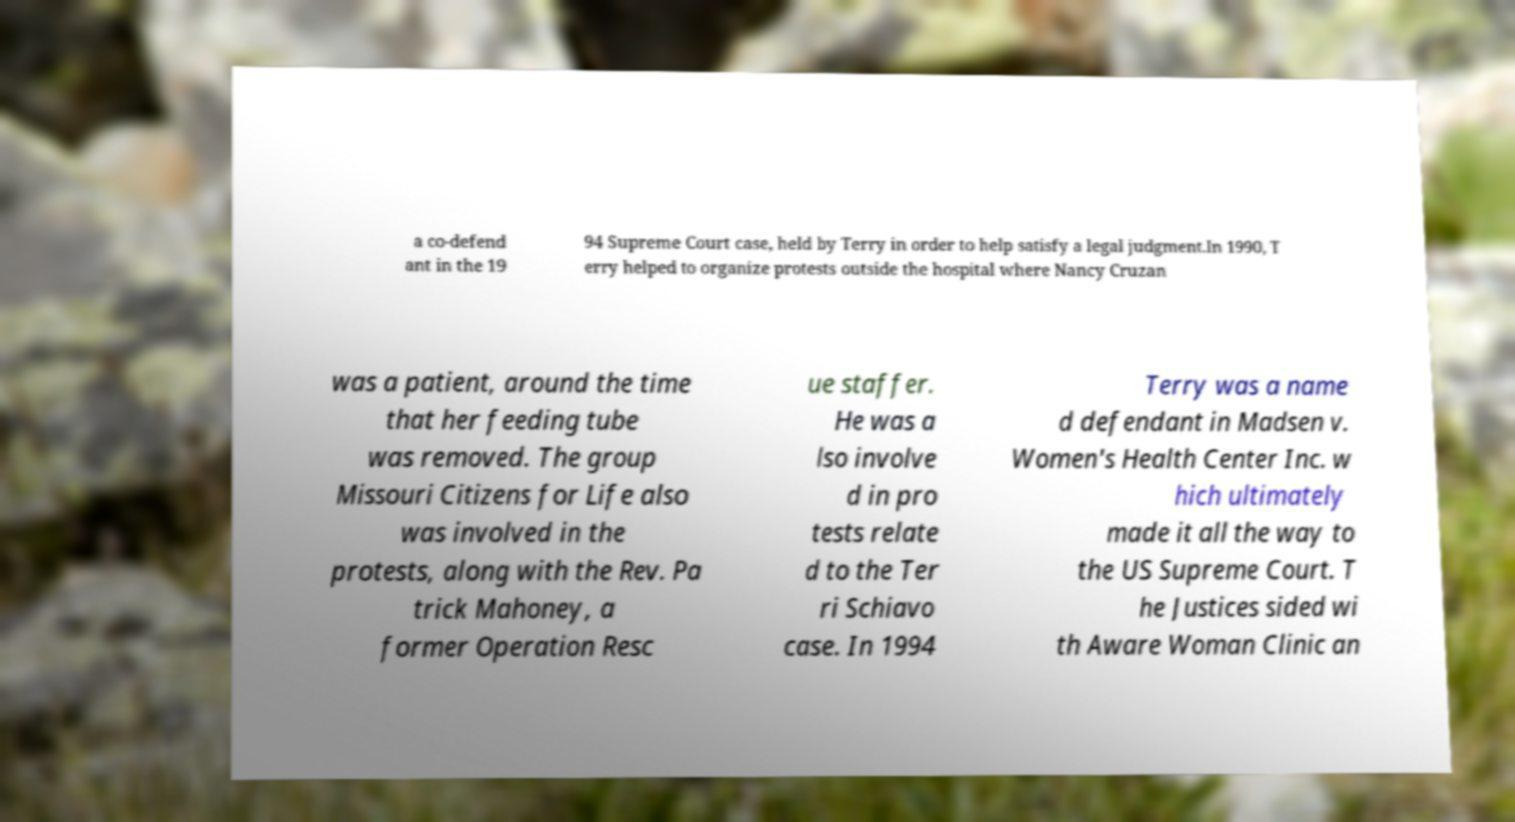Can you accurately transcribe the text from the provided image for me? a co-defend ant in the 19 94 Supreme Court case, held by Terry in order to help satisfy a legal judgment.In 1990, T erry helped to organize protests outside the hospital where Nancy Cruzan was a patient, around the time that her feeding tube was removed. The group Missouri Citizens for Life also was involved in the protests, along with the Rev. Pa trick Mahoney, a former Operation Resc ue staffer. He was a lso involve d in pro tests relate d to the Ter ri Schiavo case. In 1994 Terry was a name d defendant in Madsen v. Women's Health Center Inc. w hich ultimately made it all the way to the US Supreme Court. T he Justices sided wi th Aware Woman Clinic an 